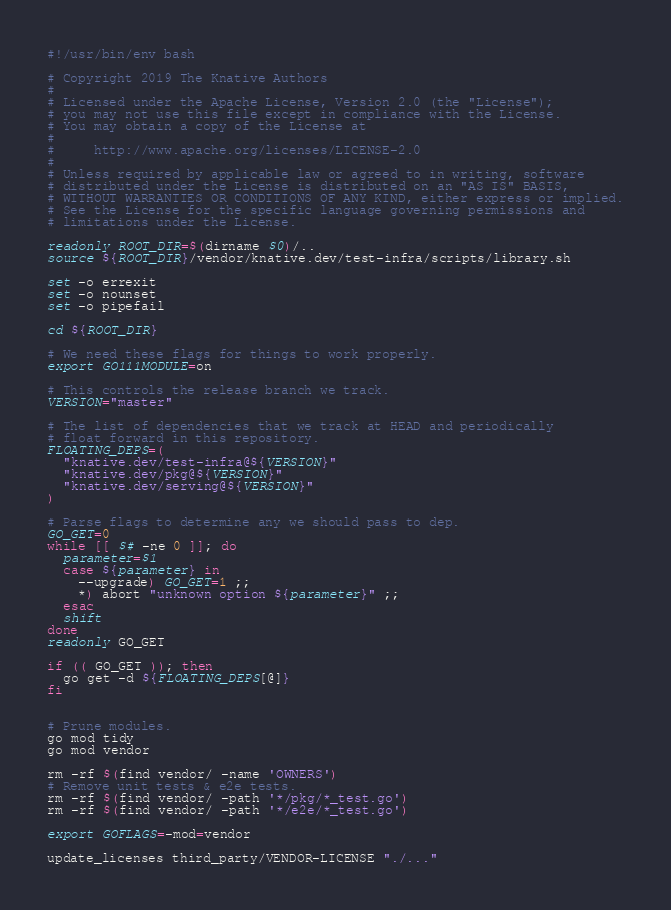Convert code to text. <code><loc_0><loc_0><loc_500><loc_500><_Bash_>#!/usr/bin/env bash

# Copyright 2019 The Knative Authors
#
# Licensed under the Apache License, Version 2.0 (the "License");
# you may not use this file except in compliance with the License.
# You may obtain a copy of the License at
#
#     http://www.apache.org/licenses/LICENSE-2.0
#
# Unless required by applicable law or agreed to in writing, software
# distributed under the License is distributed on an "AS IS" BASIS,
# WITHOUT WARRANTIES OR CONDITIONS OF ANY KIND, either express or implied.
# See the License for the specific language governing permissions and
# limitations under the License.

readonly ROOT_DIR=$(dirname $0)/..
source ${ROOT_DIR}/vendor/knative.dev/test-infra/scripts/library.sh

set -o errexit
set -o nounset
set -o pipefail

cd ${ROOT_DIR}

# We need these flags for things to work properly.
export GO111MODULE=on

# This controls the release branch we track.
VERSION="master"

# The list of dependencies that we track at HEAD and periodically
# float forward in this repository.
FLOATING_DEPS=(
  "knative.dev/test-infra@${VERSION}"
  "knative.dev/pkg@${VERSION}"
  "knative.dev/serving@${VERSION}"
)

# Parse flags to determine any we should pass to dep.
GO_GET=0
while [[ $# -ne 0 ]]; do
  parameter=$1
  case ${parameter} in
    --upgrade) GO_GET=1 ;;
    *) abort "unknown option ${parameter}" ;;
  esac
  shift
done
readonly GO_GET

if (( GO_GET )); then
  go get -d ${FLOATING_DEPS[@]}
fi


# Prune modules.
go mod tidy
go mod vendor

rm -rf $(find vendor/ -name 'OWNERS')
# Remove unit tests & e2e tests.
rm -rf $(find vendor/ -path '*/pkg/*_test.go')
rm -rf $(find vendor/ -path '*/e2e/*_test.go')

export GOFLAGS=-mod=vendor

update_licenses third_party/VENDOR-LICENSE "./..."
</code> 